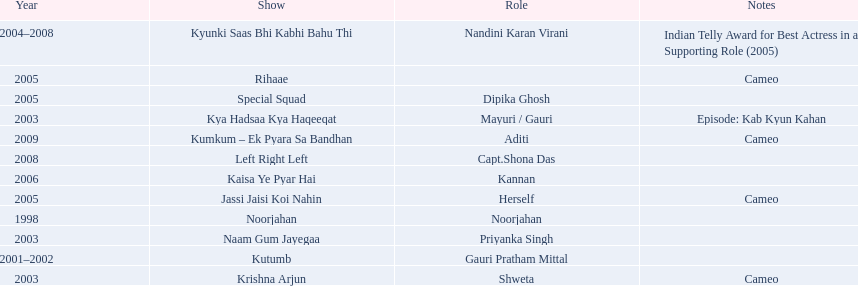Which television show was gauri in for the longest amount of time? Kyunki Saas Bhi Kabhi Bahu Thi. 